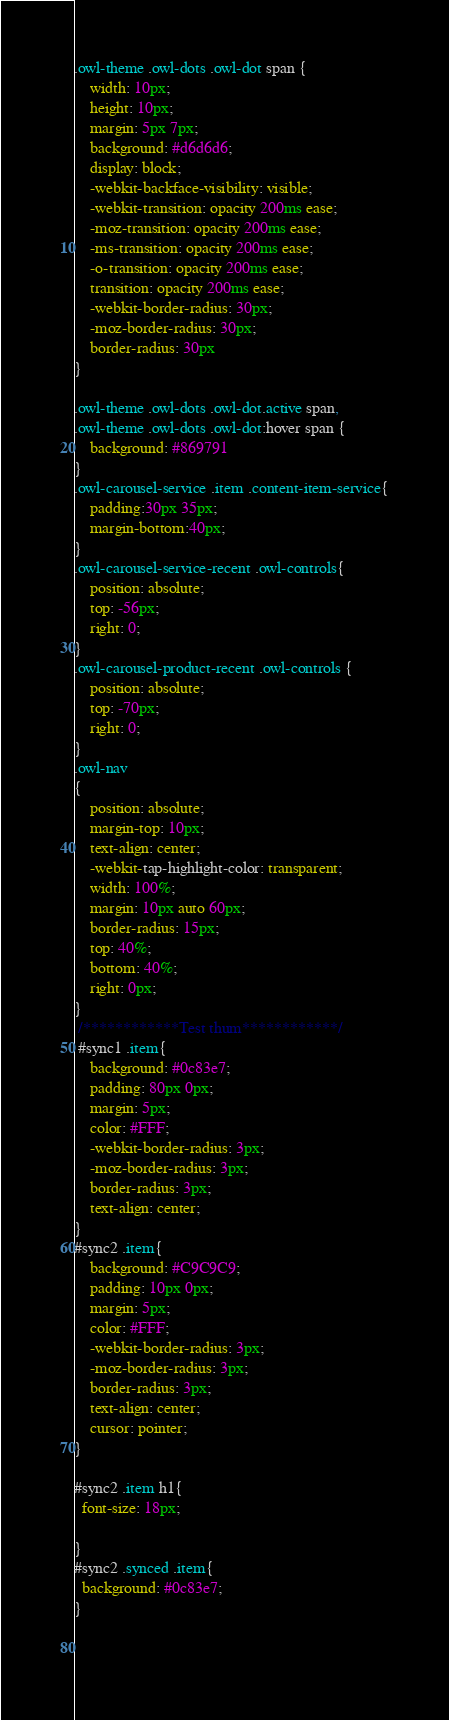<code> <loc_0><loc_0><loc_500><loc_500><_CSS_>.owl-theme .owl-dots .owl-dot span {
    width: 10px;
    height: 10px;
    margin: 5px 7px;
    background: #d6d6d6;
    display: block;
    -webkit-backface-visibility: visible;
    -webkit-transition: opacity 200ms ease;
    -moz-transition: opacity 200ms ease;
    -ms-transition: opacity 200ms ease;
    -o-transition: opacity 200ms ease;
    transition: opacity 200ms ease;
    -webkit-border-radius: 30px;
    -moz-border-radius: 30px;
    border-radius: 30px
}

.owl-theme .owl-dots .owl-dot.active span,
.owl-theme .owl-dots .owl-dot:hover span {
    background: #869791
}
.owl-carousel-service .item .content-item-service{
    padding:30px 35px;
    margin-bottom:40px;
}
.owl-carousel-service-recent .owl-controls{
    position: absolute;
    top: -56px;
    right: 0;
}
.owl-carousel-product-recent .owl-controls {
    position: absolute;
    top: -70px;
    right: 0;
}
.owl-nav
{
    position: absolute;
    margin-top: 10px;
    text-align: center;
    -webkit-tap-highlight-color: transparent;
    width: 100%;
    margin: 10px auto 60px;
    border-radius: 15px;
    top: 40%;
    bottom: 40%;
    right: 0px;
}
 /************Test thum************/
 #sync1 .item{
    background: #0c83e7;
    padding: 80px 0px;
    margin: 5px;
    color: #FFF;
    -webkit-border-radius: 3px;
    -moz-border-radius: 3px;
    border-radius: 3px;
    text-align: center;
}
#sync2 .item{
    background: #C9C9C9;
    padding: 10px 0px;
    margin: 5px;
    color: #FFF;
    -webkit-border-radius: 3px;
    -moz-border-radius: 3px;
    border-radius: 3px;
    text-align: center;
    cursor: pointer;
}

#sync2 .item h1{
  font-size: 18px;

}
#sync2 .synced .item{
  background: #0c83e7;
}

   </code> 